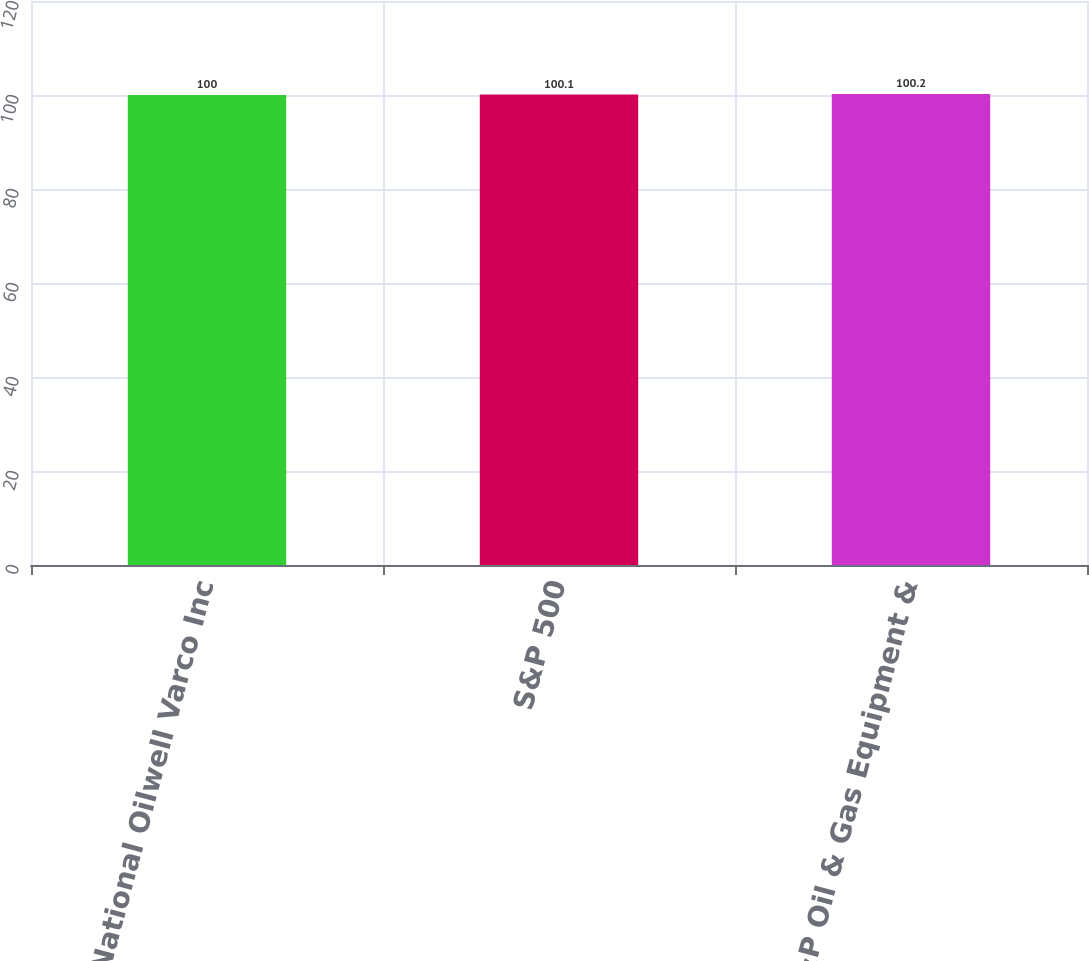Convert chart. <chart><loc_0><loc_0><loc_500><loc_500><bar_chart><fcel>National Oilwell Varco Inc<fcel>S&P 500<fcel>S&P Oil & Gas Equipment &<nl><fcel>100<fcel>100.1<fcel>100.2<nl></chart> 